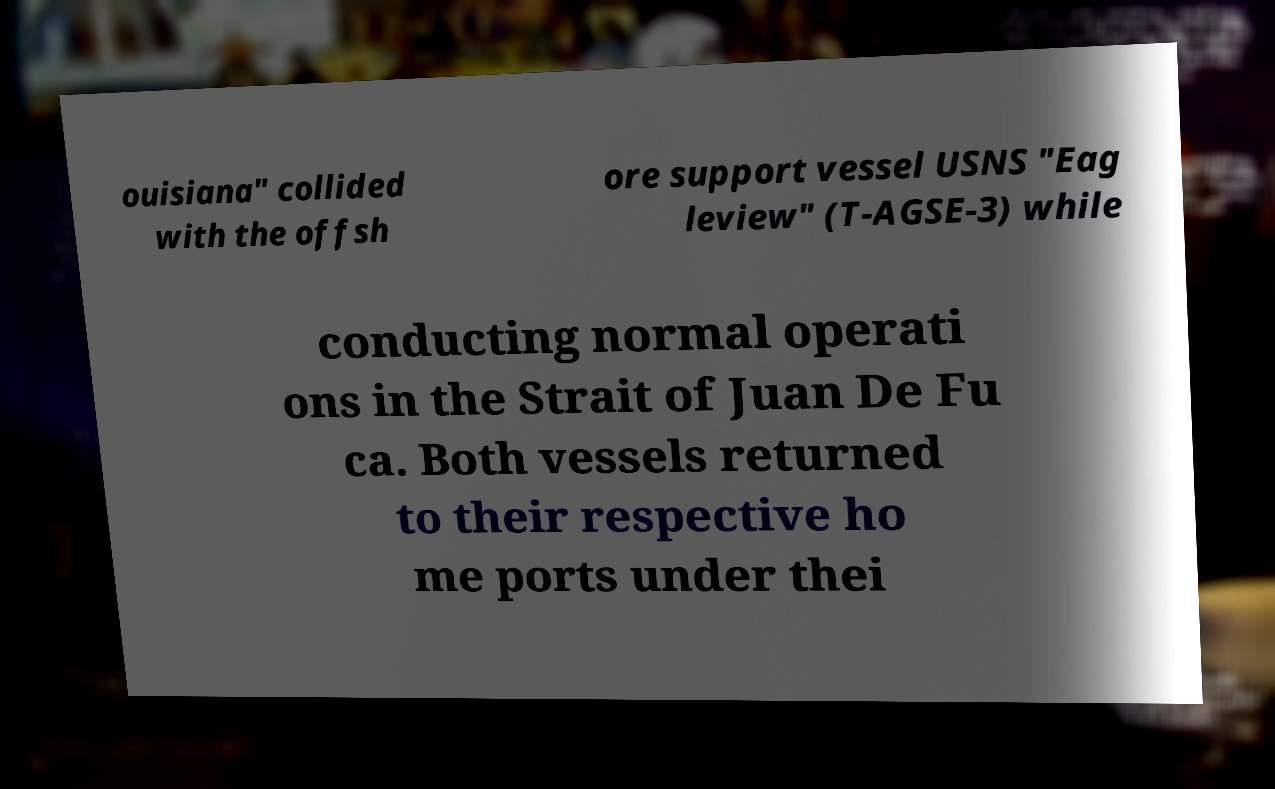Could you extract and type out the text from this image? ouisiana" collided with the offsh ore support vessel USNS "Eag leview" (T-AGSE-3) while conducting normal operati ons in the Strait of Juan De Fu ca. Both vessels returned to their respective ho me ports under thei 